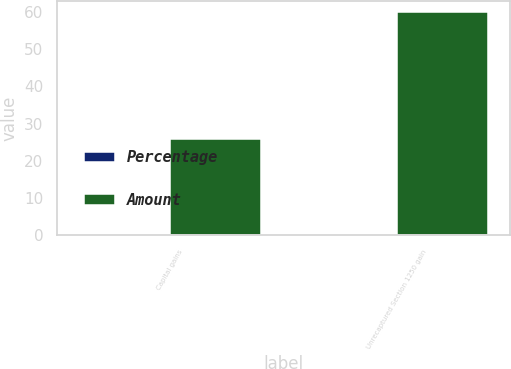Convert chart to OTSL. <chart><loc_0><loc_0><loc_500><loc_500><stacked_bar_chart><ecel><fcel>Capital gains<fcel>Unrecaptured Section 1250 gain<nl><fcel>Percentage<fcel>0.1<fcel>0.24<nl><fcel>Amount<fcel>26<fcel>60<nl></chart> 